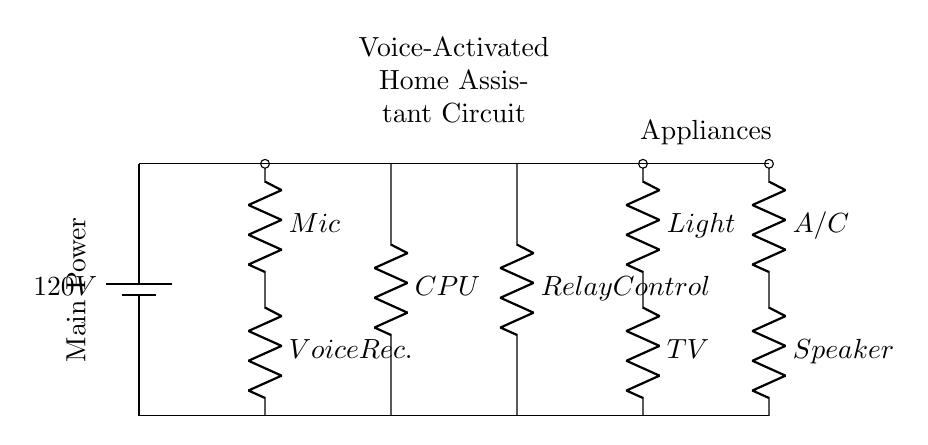What is the voltage of this circuit? The voltage provided in the circuit is 120V. This is indicated at the main power supply, where the battery is labeled clearly.
Answer: 120V What are the components used for voice activation? The components specifically for voice activation are the microphone and the voice recognition unit, which are shown connected on the left side of the circuit.
Answer: Microphone and Voice Recognition Unit How many appliances are controlled in this circuit? The circuit diagram illustrates that there are four appliances connected: Light, TV, A/C, and Speaker. Each is depicted with a resistor symbol representing its control connection.
Answer: Four Which component processes the voice commands? The component responsible for processing voice commands is the CPU, which is drawn in the central part of the circuit and connected to both the voice recognition unit and the relay control unit.
Answer: CPU How does the voice-activated system control appliances? The system controls appliances through the relay control component, which is connected to the CPU and allows for the on/off switching of appliances based on voice commands processed by the system.
Answer: Relay Control Which component supplies the main power to the circuit? The main power supply in this circuit is provided by a battery labeled as 120V, situated at the top of the circuit.
Answer: Battery What is the purpose of the relay control unit? The relay control unit serves as a switch that allows the system to control high-power appliances safely, being triggered by the signals from the CPU, enabling hands-free operation based on voice commands.
Answer: Control high-power appliances safely 